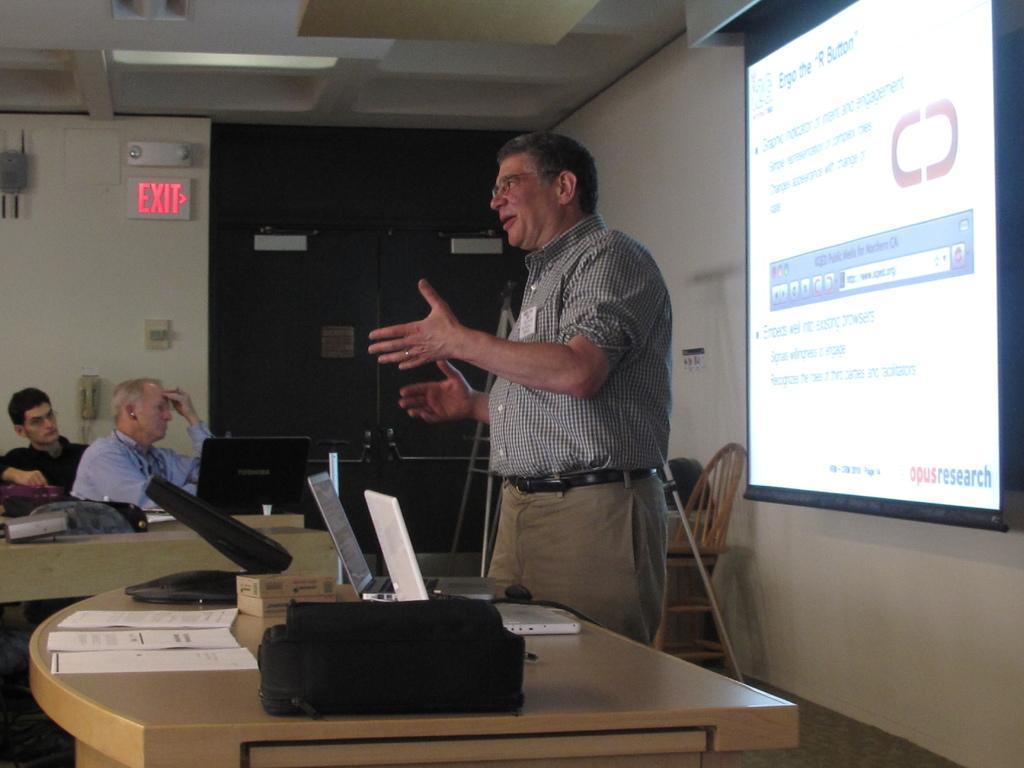Describe this image in one or two sentences. This is a picture taken in a room, there are a two people sitting on a chair and a man is standing on the floor in front of the people there is a table on the table there are laptop, paper and a bag. Background of this people there is a projector screen, wall and there is a sign board and a door which is in black color. 